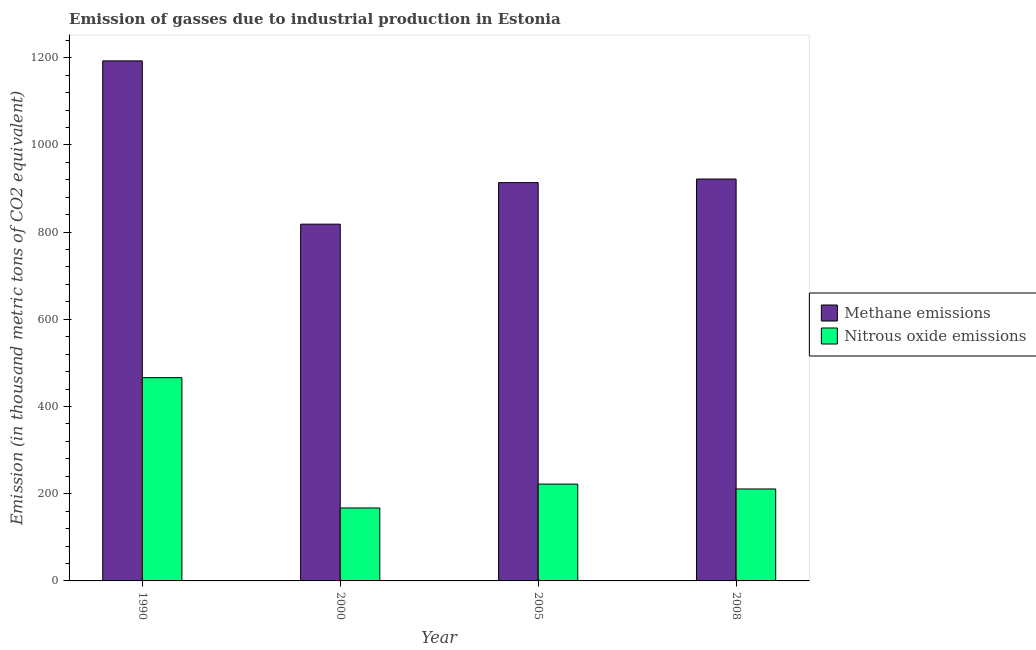Are the number of bars on each tick of the X-axis equal?
Your answer should be very brief. Yes. How many bars are there on the 1st tick from the right?
Keep it short and to the point. 2. What is the label of the 4th group of bars from the left?
Ensure brevity in your answer.  2008. In how many cases, is the number of bars for a given year not equal to the number of legend labels?
Offer a very short reply. 0. What is the amount of methane emissions in 1990?
Give a very brief answer. 1192.7. Across all years, what is the maximum amount of nitrous oxide emissions?
Your response must be concise. 466.2. Across all years, what is the minimum amount of methane emissions?
Provide a short and direct response. 818.2. In which year was the amount of methane emissions maximum?
Make the answer very short. 1990. What is the total amount of nitrous oxide emissions in the graph?
Ensure brevity in your answer.  1066.5. What is the difference between the amount of nitrous oxide emissions in 2005 and that in 2008?
Your answer should be compact. 11.2. What is the difference between the amount of methane emissions in 2000 and the amount of nitrous oxide emissions in 2005?
Offer a terse response. -95.3. What is the average amount of methane emissions per year?
Keep it short and to the point. 961.53. In how many years, is the amount of methane emissions greater than 280 thousand metric tons?
Offer a terse response. 4. What is the ratio of the amount of methane emissions in 2005 to that in 2008?
Your answer should be very brief. 0.99. Is the amount of methane emissions in 2005 less than that in 2008?
Your response must be concise. Yes. What is the difference between the highest and the second highest amount of methane emissions?
Your answer should be very brief. 271. What is the difference between the highest and the lowest amount of methane emissions?
Your answer should be compact. 374.5. In how many years, is the amount of methane emissions greater than the average amount of methane emissions taken over all years?
Keep it short and to the point. 1. What does the 1st bar from the left in 2005 represents?
Give a very brief answer. Methane emissions. What does the 1st bar from the right in 2005 represents?
Your answer should be very brief. Nitrous oxide emissions. How many years are there in the graph?
Ensure brevity in your answer.  4. Are the values on the major ticks of Y-axis written in scientific E-notation?
Offer a terse response. No. Where does the legend appear in the graph?
Provide a succinct answer. Center right. How many legend labels are there?
Provide a succinct answer. 2. What is the title of the graph?
Your response must be concise. Emission of gasses due to industrial production in Estonia. What is the label or title of the Y-axis?
Your answer should be compact. Emission (in thousand metric tons of CO2 equivalent). What is the Emission (in thousand metric tons of CO2 equivalent) of Methane emissions in 1990?
Keep it short and to the point. 1192.7. What is the Emission (in thousand metric tons of CO2 equivalent) of Nitrous oxide emissions in 1990?
Your answer should be very brief. 466.2. What is the Emission (in thousand metric tons of CO2 equivalent) of Methane emissions in 2000?
Your answer should be very brief. 818.2. What is the Emission (in thousand metric tons of CO2 equivalent) of Nitrous oxide emissions in 2000?
Your answer should be compact. 167.3. What is the Emission (in thousand metric tons of CO2 equivalent) in Methane emissions in 2005?
Give a very brief answer. 913.5. What is the Emission (in thousand metric tons of CO2 equivalent) in Nitrous oxide emissions in 2005?
Your response must be concise. 222.1. What is the Emission (in thousand metric tons of CO2 equivalent) of Methane emissions in 2008?
Provide a short and direct response. 921.7. What is the Emission (in thousand metric tons of CO2 equivalent) of Nitrous oxide emissions in 2008?
Offer a terse response. 210.9. Across all years, what is the maximum Emission (in thousand metric tons of CO2 equivalent) of Methane emissions?
Your answer should be compact. 1192.7. Across all years, what is the maximum Emission (in thousand metric tons of CO2 equivalent) in Nitrous oxide emissions?
Ensure brevity in your answer.  466.2. Across all years, what is the minimum Emission (in thousand metric tons of CO2 equivalent) of Methane emissions?
Your answer should be compact. 818.2. Across all years, what is the minimum Emission (in thousand metric tons of CO2 equivalent) in Nitrous oxide emissions?
Provide a succinct answer. 167.3. What is the total Emission (in thousand metric tons of CO2 equivalent) of Methane emissions in the graph?
Provide a succinct answer. 3846.1. What is the total Emission (in thousand metric tons of CO2 equivalent) in Nitrous oxide emissions in the graph?
Provide a succinct answer. 1066.5. What is the difference between the Emission (in thousand metric tons of CO2 equivalent) of Methane emissions in 1990 and that in 2000?
Make the answer very short. 374.5. What is the difference between the Emission (in thousand metric tons of CO2 equivalent) in Nitrous oxide emissions in 1990 and that in 2000?
Keep it short and to the point. 298.9. What is the difference between the Emission (in thousand metric tons of CO2 equivalent) in Methane emissions in 1990 and that in 2005?
Offer a very short reply. 279.2. What is the difference between the Emission (in thousand metric tons of CO2 equivalent) of Nitrous oxide emissions in 1990 and that in 2005?
Provide a succinct answer. 244.1. What is the difference between the Emission (in thousand metric tons of CO2 equivalent) in Methane emissions in 1990 and that in 2008?
Provide a short and direct response. 271. What is the difference between the Emission (in thousand metric tons of CO2 equivalent) of Nitrous oxide emissions in 1990 and that in 2008?
Your response must be concise. 255.3. What is the difference between the Emission (in thousand metric tons of CO2 equivalent) in Methane emissions in 2000 and that in 2005?
Your answer should be compact. -95.3. What is the difference between the Emission (in thousand metric tons of CO2 equivalent) of Nitrous oxide emissions in 2000 and that in 2005?
Make the answer very short. -54.8. What is the difference between the Emission (in thousand metric tons of CO2 equivalent) of Methane emissions in 2000 and that in 2008?
Your response must be concise. -103.5. What is the difference between the Emission (in thousand metric tons of CO2 equivalent) of Nitrous oxide emissions in 2000 and that in 2008?
Your answer should be compact. -43.6. What is the difference between the Emission (in thousand metric tons of CO2 equivalent) of Methane emissions in 1990 and the Emission (in thousand metric tons of CO2 equivalent) of Nitrous oxide emissions in 2000?
Make the answer very short. 1025.4. What is the difference between the Emission (in thousand metric tons of CO2 equivalent) of Methane emissions in 1990 and the Emission (in thousand metric tons of CO2 equivalent) of Nitrous oxide emissions in 2005?
Keep it short and to the point. 970.6. What is the difference between the Emission (in thousand metric tons of CO2 equivalent) of Methane emissions in 1990 and the Emission (in thousand metric tons of CO2 equivalent) of Nitrous oxide emissions in 2008?
Offer a very short reply. 981.8. What is the difference between the Emission (in thousand metric tons of CO2 equivalent) in Methane emissions in 2000 and the Emission (in thousand metric tons of CO2 equivalent) in Nitrous oxide emissions in 2005?
Keep it short and to the point. 596.1. What is the difference between the Emission (in thousand metric tons of CO2 equivalent) of Methane emissions in 2000 and the Emission (in thousand metric tons of CO2 equivalent) of Nitrous oxide emissions in 2008?
Provide a short and direct response. 607.3. What is the difference between the Emission (in thousand metric tons of CO2 equivalent) in Methane emissions in 2005 and the Emission (in thousand metric tons of CO2 equivalent) in Nitrous oxide emissions in 2008?
Provide a short and direct response. 702.6. What is the average Emission (in thousand metric tons of CO2 equivalent) of Methane emissions per year?
Provide a succinct answer. 961.52. What is the average Emission (in thousand metric tons of CO2 equivalent) in Nitrous oxide emissions per year?
Provide a short and direct response. 266.62. In the year 1990, what is the difference between the Emission (in thousand metric tons of CO2 equivalent) of Methane emissions and Emission (in thousand metric tons of CO2 equivalent) of Nitrous oxide emissions?
Keep it short and to the point. 726.5. In the year 2000, what is the difference between the Emission (in thousand metric tons of CO2 equivalent) of Methane emissions and Emission (in thousand metric tons of CO2 equivalent) of Nitrous oxide emissions?
Your response must be concise. 650.9. In the year 2005, what is the difference between the Emission (in thousand metric tons of CO2 equivalent) in Methane emissions and Emission (in thousand metric tons of CO2 equivalent) in Nitrous oxide emissions?
Your answer should be compact. 691.4. In the year 2008, what is the difference between the Emission (in thousand metric tons of CO2 equivalent) of Methane emissions and Emission (in thousand metric tons of CO2 equivalent) of Nitrous oxide emissions?
Provide a short and direct response. 710.8. What is the ratio of the Emission (in thousand metric tons of CO2 equivalent) in Methane emissions in 1990 to that in 2000?
Your answer should be compact. 1.46. What is the ratio of the Emission (in thousand metric tons of CO2 equivalent) in Nitrous oxide emissions in 1990 to that in 2000?
Your response must be concise. 2.79. What is the ratio of the Emission (in thousand metric tons of CO2 equivalent) in Methane emissions in 1990 to that in 2005?
Your answer should be very brief. 1.31. What is the ratio of the Emission (in thousand metric tons of CO2 equivalent) of Nitrous oxide emissions in 1990 to that in 2005?
Your answer should be compact. 2.1. What is the ratio of the Emission (in thousand metric tons of CO2 equivalent) in Methane emissions in 1990 to that in 2008?
Your answer should be very brief. 1.29. What is the ratio of the Emission (in thousand metric tons of CO2 equivalent) of Nitrous oxide emissions in 1990 to that in 2008?
Make the answer very short. 2.21. What is the ratio of the Emission (in thousand metric tons of CO2 equivalent) of Methane emissions in 2000 to that in 2005?
Give a very brief answer. 0.9. What is the ratio of the Emission (in thousand metric tons of CO2 equivalent) of Nitrous oxide emissions in 2000 to that in 2005?
Your answer should be very brief. 0.75. What is the ratio of the Emission (in thousand metric tons of CO2 equivalent) in Methane emissions in 2000 to that in 2008?
Give a very brief answer. 0.89. What is the ratio of the Emission (in thousand metric tons of CO2 equivalent) of Nitrous oxide emissions in 2000 to that in 2008?
Offer a very short reply. 0.79. What is the ratio of the Emission (in thousand metric tons of CO2 equivalent) of Methane emissions in 2005 to that in 2008?
Keep it short and to the point. 0.99. What is the ratio of the Emission (in thousand metric tons of CO2 equivalent) in Nitrous oxide emissions in 2005 to that in 2008?
Ensure brevity in your answer.  1.05. What is the difference between the highest and the second highest Emission (in thousand metric tons of CO2 equivalent) of Methane emissions?
Your response must be concise. 271. What is the difference between the highest and the second highest Emission (in thousand metric tons of CO2 equivalent) of Nitrous oxide emissions?
Provide a short and direct response. 244.1. What is the difference between the highest and the lowest Emission (in thousand metric tons of CO2 equivalent) in Methane emissions?
Provide a succinct answer. 374.5. What is the difference between the highest and the lowest Emission (in thousand metric tons of CO2 equivalent) of Nitrous oxide emissions?
Offer a terse response. 298.9. 